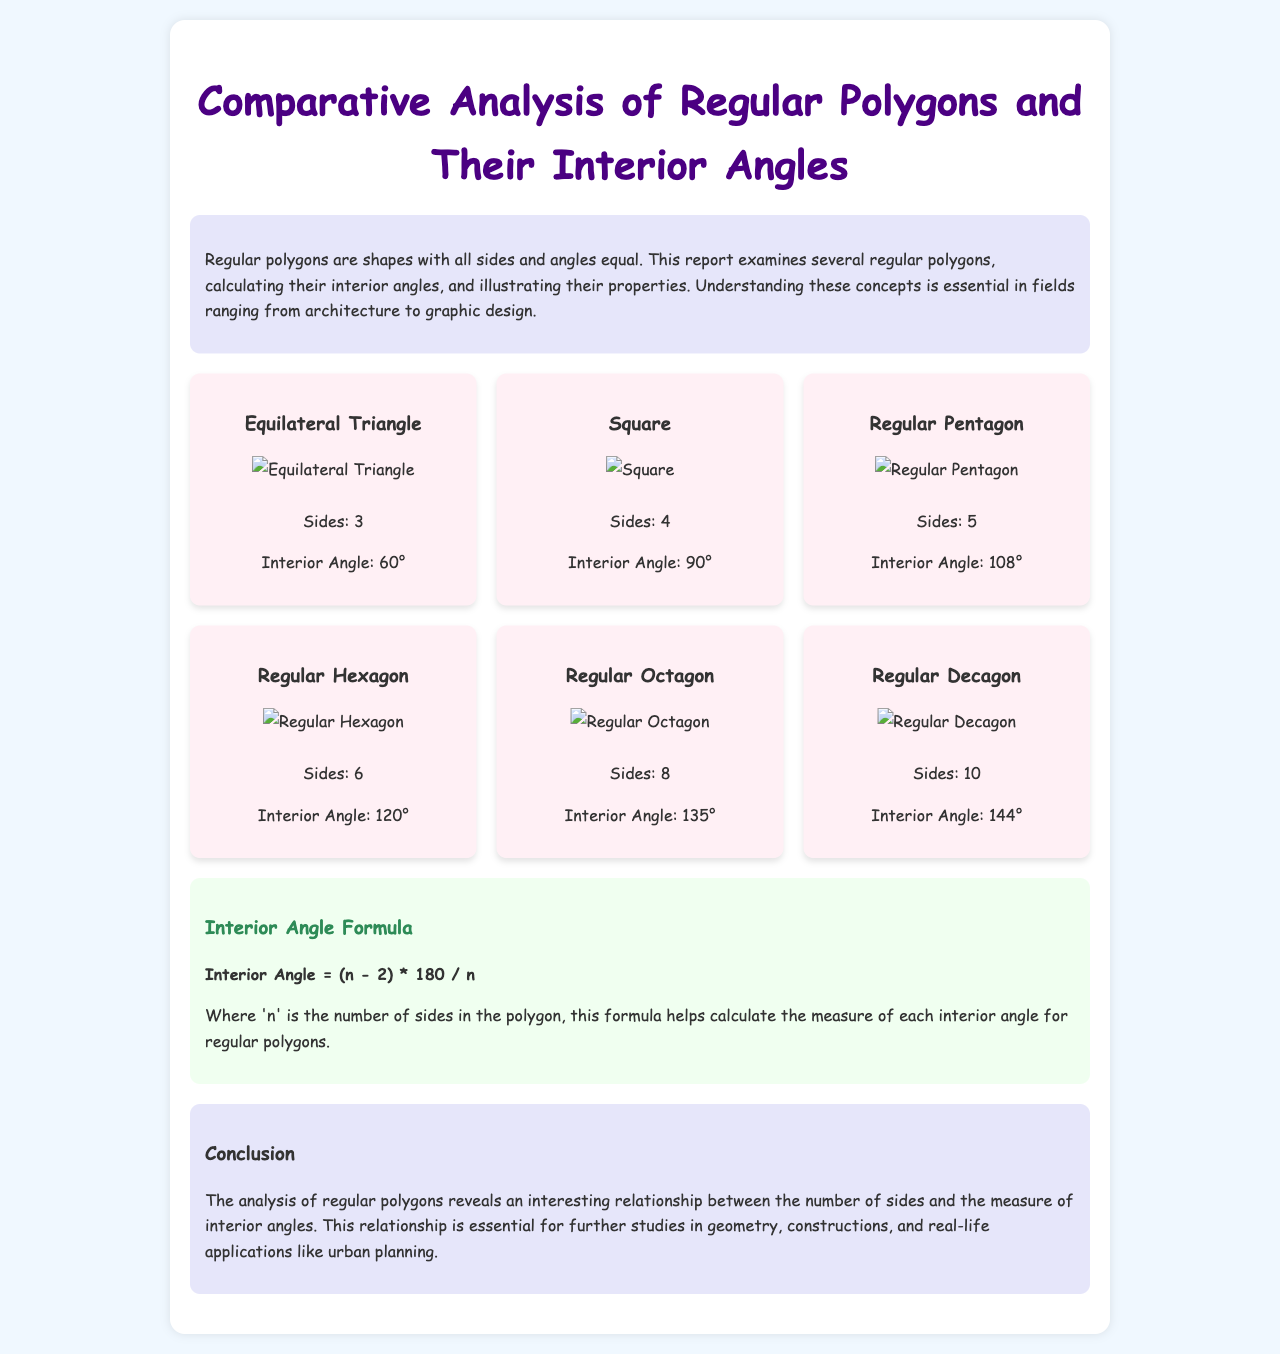What is the shape with 3 sides? The equilateral triangle is identified as having 3 sides in the document.
Answer: Equilateral Triangle What is the interior angle of a square? The document states that the interior angle of a square is 90 degrees.
Answer: 90° How many sides does a regular hexagon have? The document provides that a regular hexagon has 6 sides.
Answer: 6 What formula is given for calculating the interior angles? The interior angle formula provided in the document is (n - 2) * 180 / n.
Answer: (n - 2) * 180 / n Which polygon has an interior angle of 144 degrees? The regular decagon is mentioned in the document as having an interior angle of 144 degrees.
Answer: Regular Decagon How does the number of sides affect the interior angle? The document explains that the analysis reveals a relationship between the number of sides and the measure of interior angles.
Answer: Relationship What is the background color of the document? The report specifies that the background color is light blue (f0f8ff).
Answer: Light blue In which fields is understanding regular polygons important? The document highlights that understanding these concepts is essential in fields like architecture and graphic design.
Answer: Architecture, graphic design 